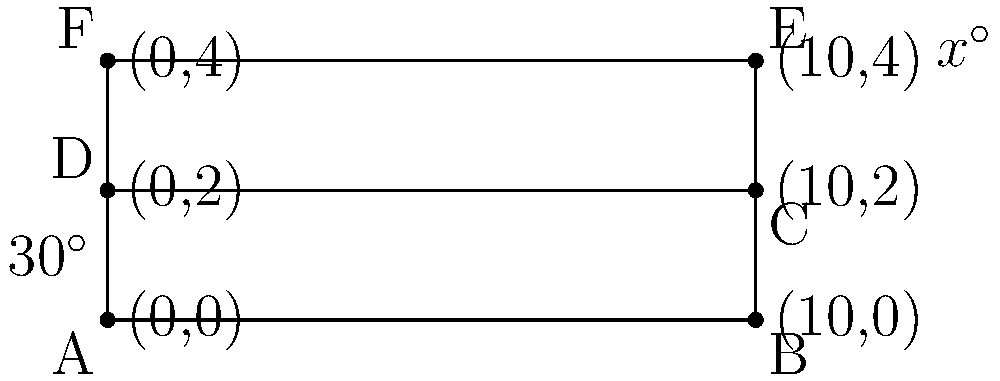As a concerned Jacksonville resident, you're helping design an accessible ramp for a public building. The ramp needs to have a gentle slope for easy wheelchair access. Given that the angle at the base of the ramp is 30°, what is the value of angle $x$ at the top of the ramp? Let's approach this step-by-step:

1) First, notice that the lines AD and BE are parallel (they're both vertical sides of the rectangle).

2) The line AF is a transversal that crosses these parallel lines.

3) When a transversal crosses parallel lines, corresponding angles are equal. Therefore, the angle at A (which is 30°) is equal to the alternate interior angle at F.

4) In the triangle FDE:
   - We know one angle is 30° (the angle at F)
   - The angle at D is a right angle (90°), as it's the corner of a rectangle

5) In any triangle, the sum of all angles is 180°. So we can set up an equation:

   $$30^\circ + 90^\circ + x^\circ = 180^\circ$$

6) Simplifying:
   $$120^\circ + x^\circ = 180^\circ$$

7) Solving for $x$:
   $$x^\circ = 180^\circ - 120^\circ = 60^\circ$$

Therefore, the angle $x$ at the top of the ramp is 60°.
Answer: 60° 